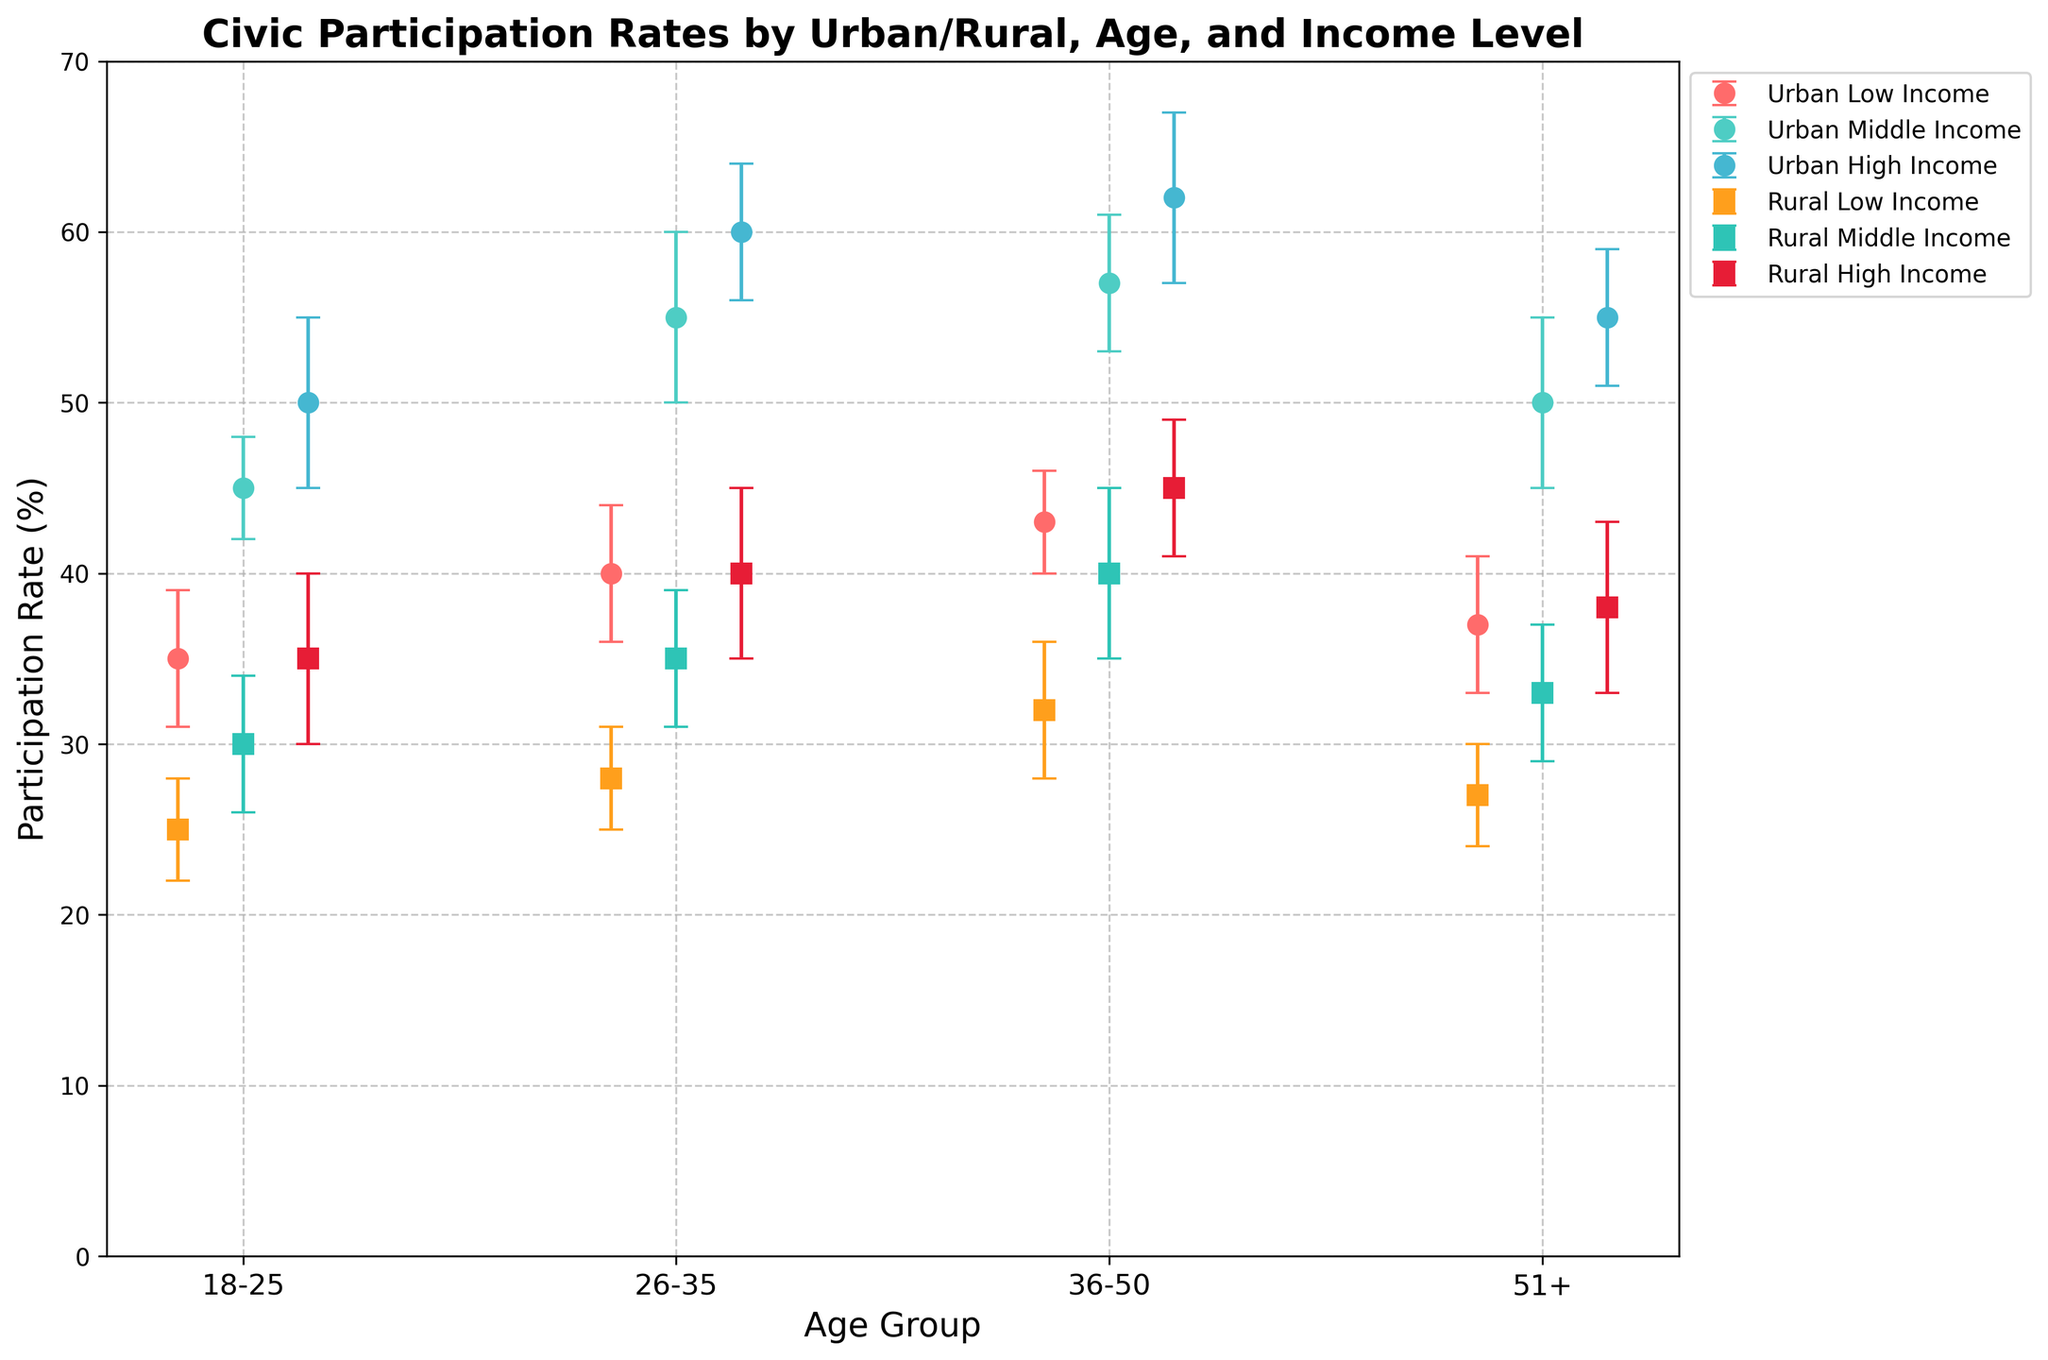What is the title of the plot? The title is prominently displayed at the top of the plot. It usually gives an overview of what the plot is about. In this case, it reads, "Civic Participation Rates by Urban/Rural, Age, and Income Level."
Answer: Civic Participation Rates by Urban/Rural, Age, and Income Level Which age group has the highest participation rate in urban high-income settings? By looking at the urban high-income data points, we can identify the age group with the highest participation rate. The 36-50 age group in the urban high-income setting has a participation rate of 62%.
Answer: 36-50 Compare the participation rates of rural low-income and middle-income groups for ages 26-35. Which one is higher? We check the participation rates for rural low-income and middle-income groups within the 26-35 age group. The middle-income group has a participation rate of 35%, while the low-income group has a participation rate of 28%. Therefore, the middle-income group's participation rate is higher.
Answer: Middle-income group What is the difference in participation rates between urban middle-income and high-income groups in the 18-25 age group? First, note the participation rates for urban middle-income and high-income groups within the 18-25 age group. The middle-income group's rate is 45%, and the high-income group's rate is 50%. The difference is calculated by subtracting 45% from 50%, which results in a 5% difference.
Answer: 5% Which group exhibits the lowest civic participation rate? To identify the group with the lowest participation rate, we examine all data points across both urban and rural settings, as well as all age and income levels. The rural low-income group within the 18-25 age group has the lowest participation rate of 25%.
Answer: Rural low-income (18-25 age group) For the urban middle-income group, how much does the error bar span for the 26-35 age group? The plot error bar indicates the variability or uncertainty in the data. For the urban middle-income group within the 26-35 age group, the participation rate is 55%, with an error of 5%. The error bar spans 55% ± 5%, meaning it ranges from 50% to 60%.
Answer: 10% Compare the participation rates of urban and rural high-income groups for ages 51+. Which one shows higher participation? We look at the participation rates for both urban and rural high-income groups within the 51+ age group. The urban high-income group has a participation rate of 55%, while the rural high-income group has a participation rate of 38%. Therefore, the urban high-income group's participation rate is higher.
Answer: Urban high-income group What is the average participation rate for the rural group in the 36-50 age group across all income levels? To find the average, add the participation rates for rural low-income, middle-income, and high-income groups within the 36-50 age group. The rates are 32%, 40%, and 45%, respectively. The sum is 32 + 40 + 45 = 117. Divide this by 3 to get the average: 117 / 3 = 39%.
Answer: 39% Is there a significant difference in participation rates between rural middle-income and urban low-income groups across all age groups? By comparing the rural middle-income participation rates to the urban low-income rates for each age group: 
- 18-25: 30% (rural) vs. 35% (urban)
- 26-35: 35% (rural) vs. 40% (urban)
- 36-50: 40% (rural) vs. 43% (urban)
- 51+: 33% (rural) vs. 37% (urban)
In each case, urban low-income rates are slightly higher than rural middle-income rates.
Answer: Yes Which urban age group has the smallest error bar among middle-income groups? The error bar represents the uncertainty in the data. For the urban middle-income group:
- 18-25: ±3%
- 26-35: ±5%
- 36-50: ±4%
- 51+: ±5%
The smallest error bar is ±3%, which corresponds to the 18-25 age group.
Answer: 18-25 